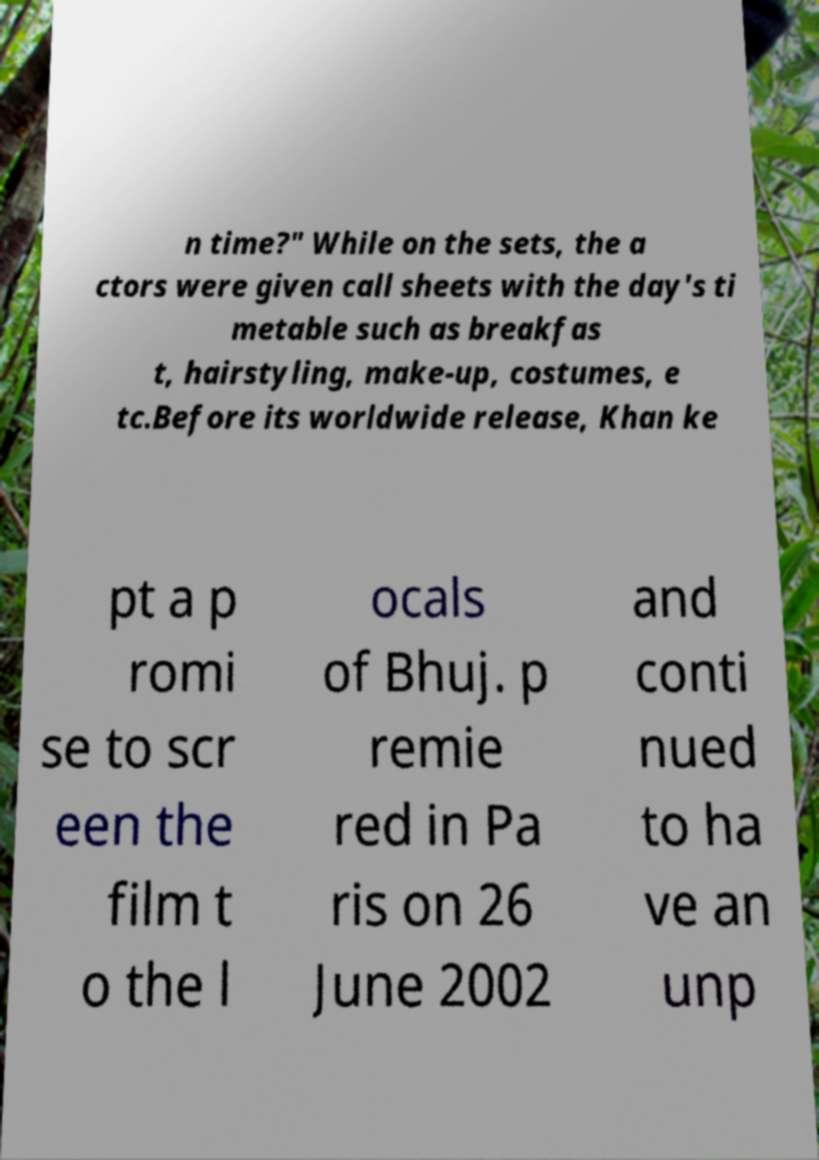I need the written content from this picture converted into text. Can you do that? n time?" While on the sets, the a ctors were given call sheets with the day's ti metable such as breakfas t, hairstyling, make-up, costumes, e tc.Before its worldwide release, Khan ke pt a p romi se to scr een the film t o the l ocals of Bhuj. p remie red in Pa ris on 26 June 2002 and conti nued to ha ve an unp 